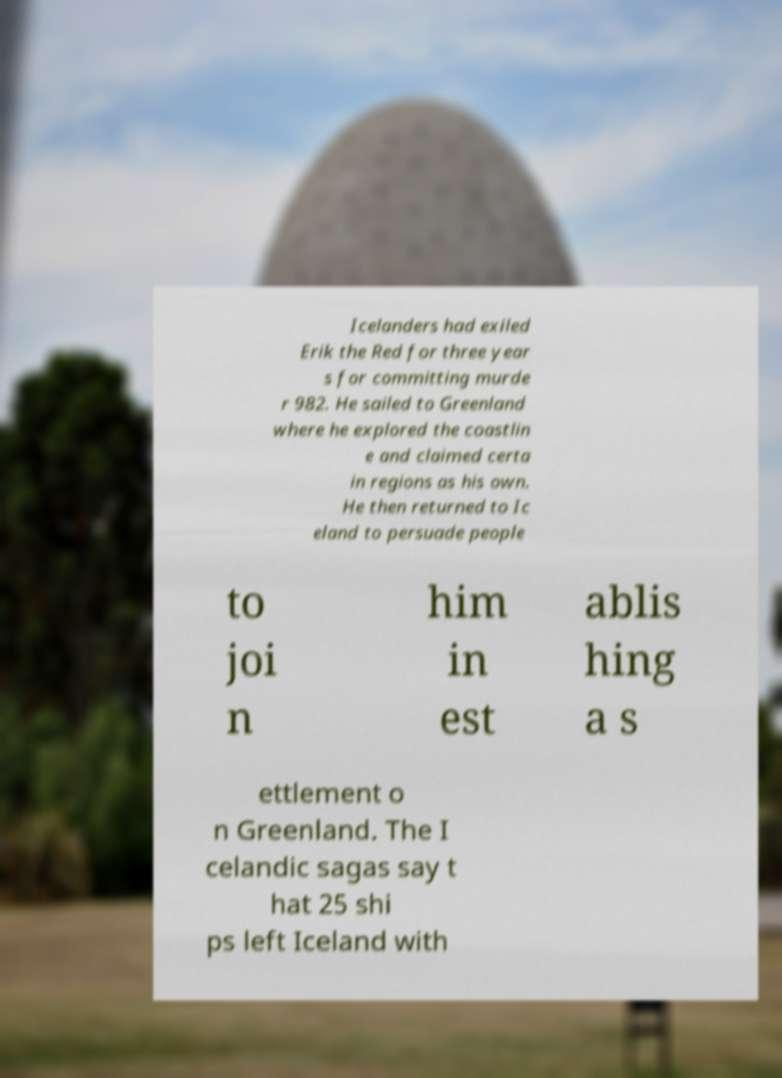For documentation purposes, I need the text within this image transcribed. Could you provide that? Icelanders had exiled Erik the Red for three year s for committing murde r 982. He sailed to Greenland where he explored the coastlin e and claimed certa in regions as his own. He then returned to Ic eland to persuade people to joi n him in est ablis hing a s ettlement o n Greenland. The I celandic sagas say t hat 25 shi ps left Iceland with 